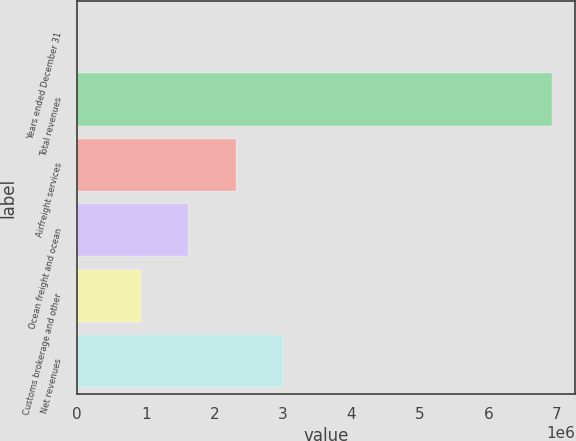Convert chart. <chart><loc_0><loc_0><loc_500><loc_500><bar_chart><fcel>Years ended December 31<fcel>Total revenues<fcel>Airfreight services<fcel>Ocean freight and ocean<fcel>Customs brokerage and other<fcel>Net revenues<nl><fcel>2017<fcel>6.92095e+06<fcel>2.31504e+06<fcel>1.62315e+06<fcel>931258<fcel>3.00694e+06<nl></chart> 